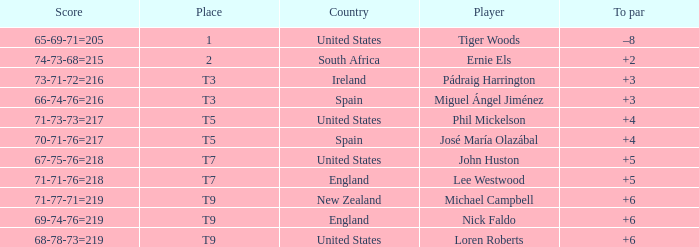What is Score, when Country is "United States", and when To Par is "+4"? 71-73-73=217. 